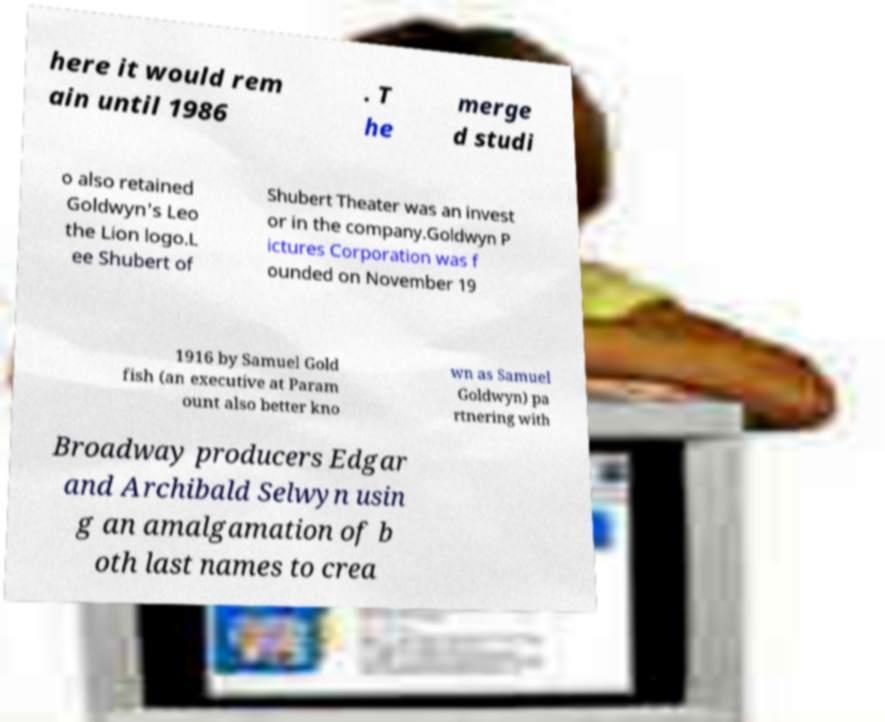For documentation purposes, I need the text within this image transcribed. Could you provide that? here it would rem ain until 1986 . T he merge d studi o also retained Goldwyn's Leo the Lion logo.L ee Shubert of Shubert Theater was an invest or in the company.Goldwyn P ictures Corporation was f ounded on November 19 1916 by Samuel Gold fish (an executive at Param ount also better kno wn as Samuel Goldwyn) pa rtnering with Broadway producers Edgar and Archibald Selwyn usin g an amalgamation of b oth last names to crea 